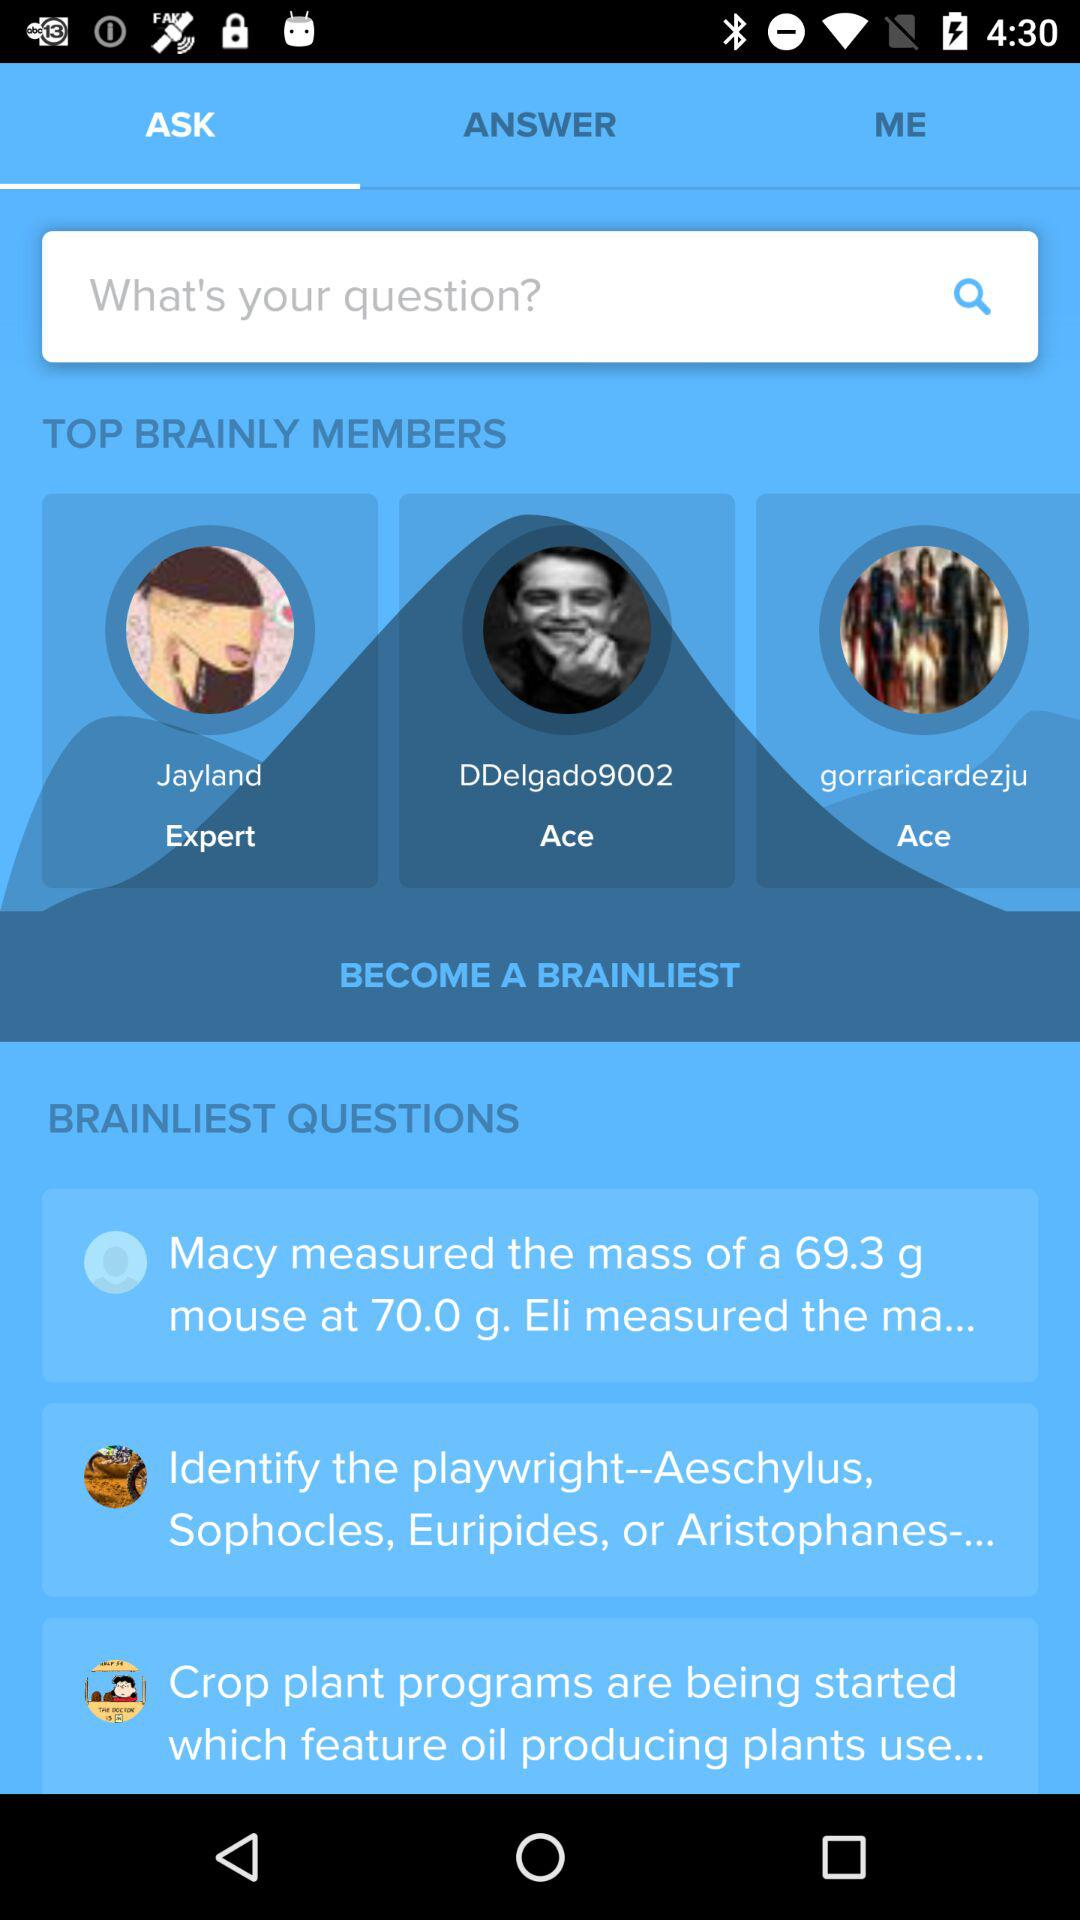When did "Jayland" become a "BRAINLY" member?
When the provided information is insufficient, respond with <no answer>. <no answer> 